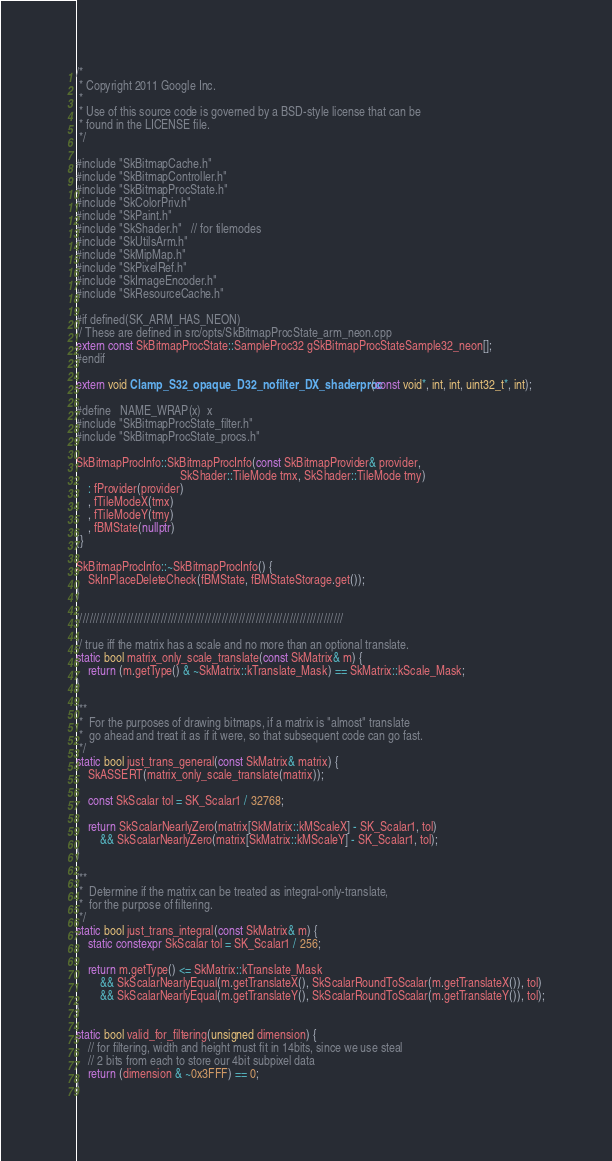<code> <loc_0><loc_0><loc_500><loc_500><_C++_>/*
 * Copyright 2011 Google Inc.
 *
 * Use of this source code is governed by a BSD-style license that can be
 * found in the LICENSE file.
 */

#include "SkBitmapCache.h"
#include "SkBitmapController.h"
#include "SkBitmapProcState.h"
#include "SkColorPriv.h"
#include "SkPaint.h"
#include "SkShader.h"   // for tilemodes
#include "SkUtilsArm.h"
#include "SkMipMap.h"
#include "SkPixelRef.h"
#include "SkImageEncoder.h"
#include "SkResourceCache.h"

#if defined(SK_ARM_HAS_NEON)
// These are defined in src/opts/SkBitmapProcState_arm_neon.cpp
extern const SkBitmapProcState::SampleProc32 gSkBitmapProcStateSample32_neon[];
#endif

extern void Clamp_S32_opaque_D32_nofilter_DX_shaderproc(const void*, int, int, uint32_t*, int);

#define   NAME_WRAP(x)  x
#include "SkBitmapProcState_filter.h"
#include "SkBitmapProcState_procs.h"

SkBitmapProcInfo::SkBitmapProcInfo(const SkBitmapProvider& provider,
                                   SkShader::TileMode tmx, SkShader::TileMode tmy)
    : fProvider(provider)
    , fTileModeX(tmx)
    , fTileModeY(tmy)
    , fBMState(nullptr)
{}

SkBitmapProcInfo::~SkBitmapProcInfo() {
    SkInPlaceDeleteCheck(fBMState, fBMStateStorage.get());
}

///////////////////////////////////////////////////////////////////////////////

// true iff the matrix has a scale and no more than an optional translate.
static bool matrix_only_scale_translate(const SkMatrix& m) {
    return (m.getType() & ~SkMatrix::kTranslate_Mask) == SkMatrix::kScale_Mask;
}

/**
 *  For the purposes of drawing bitmaps, if a matrix is "almost" translate
 *  go ahead and treat it as if it were, so that subsequent code can go fast.
 */
static bool just_trans_general(const SkMatrix& matrix) {
    SkASSERT(matrix_only_scale_translate(matrix));

    const SkScalar tol = SK_Scalar1 / 32768;

    return SkScalarNearlyZero(matrix[SkMatrix::kMScaleX] - SK_Scalar1, tol)
        && SkScalarNearlyZero(matrix[SkMatrix::kMScaleY] - SK_Scalar1, tol);
}

/**
 *  Determine if the matrix can be treated as integral-only-translate,
 *  for the purpose of filtering.
 */
static bool just_trans_integral(const SkMatrix& m) {
    static constexpr SkScalar tol = SK_Scalar1 / 256;

    return m.getType() <= SkMatrix::kTranslate_Mask
        && SkScalarNearlyEqual(m.getTranslateX(), SkScalarRoundToScalar(m.getTranslateX()), tol)
        && SkScalarNearlyEqual(m.getTranslateY(), SkScalarRoundToScalar(m.getTranslateY()), tol);
}

static bool valid_for_filtering(unsigned dimension) {
    // for filtering, width and height must fit in 14bits, since we use steal
    // 2 bits from each to store our 4bit subpixel data
    return (dimension & ~0x3FFF) == 0;
}
</code> 